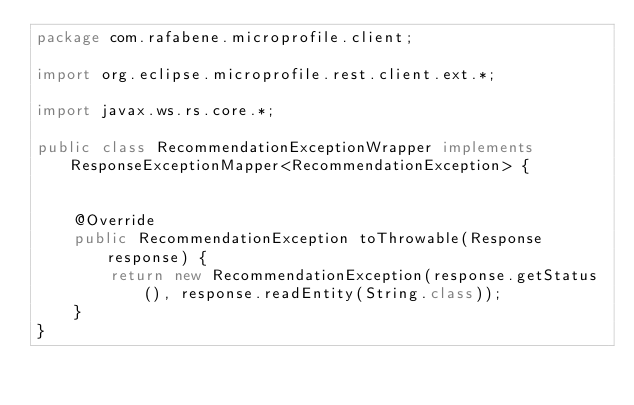Convert code to text. <code><loc_0><loc_0><loc_500><loc_500><_Java_>package com.rafabene.microprofile.client;

import org.eclipse.microprofile.rest.client.ext.*;

import javax.ws.rs.core.*;

public class RecommendationExceptionWrapper implements ResponseExceptionMapper<RecommendationException> {


    @Override
    public RecommendationException toThrowable(Response response) {
        return new RecommendationException(response.getStatus(), response.readEntity(String.class));
    }
}
</code> 